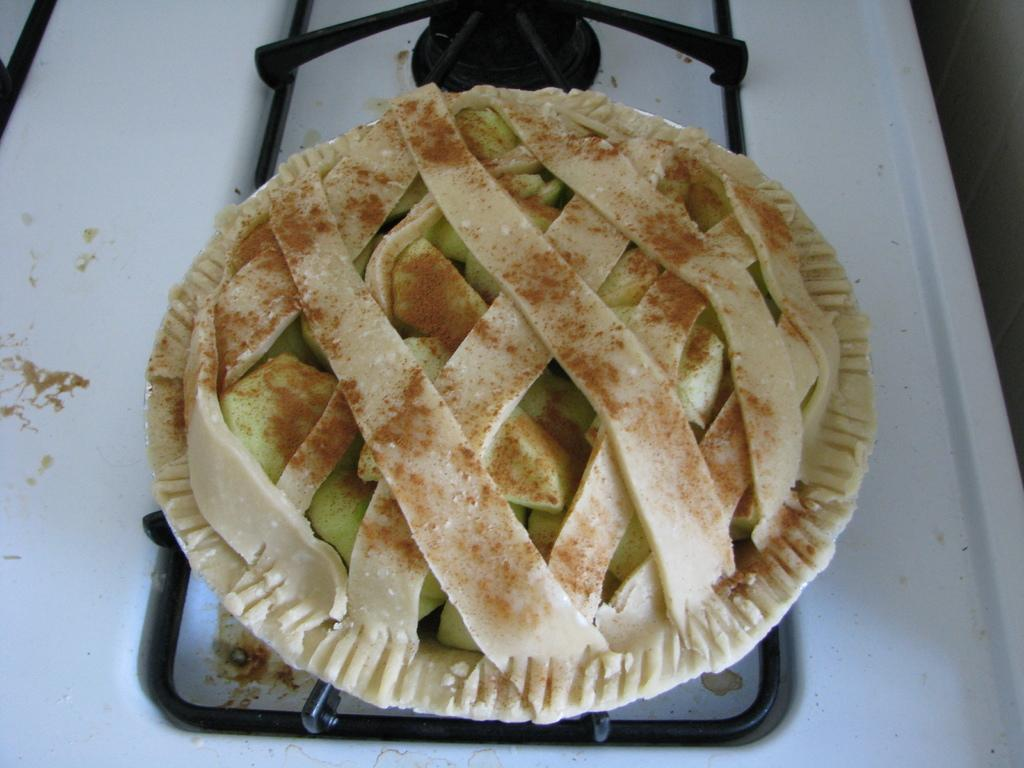What is being prepared on the stove in the image? There is food on the stove in the image. What can be seen on the right side of the image? There is a wall on the right side of the image. Is there a tub filled with water on the left side of the image? There is no tub present in the image. What is the base material of the wall on the right side of the image? The provided facts do not mention the base material of the wall, so it cannot be determined from the image. 